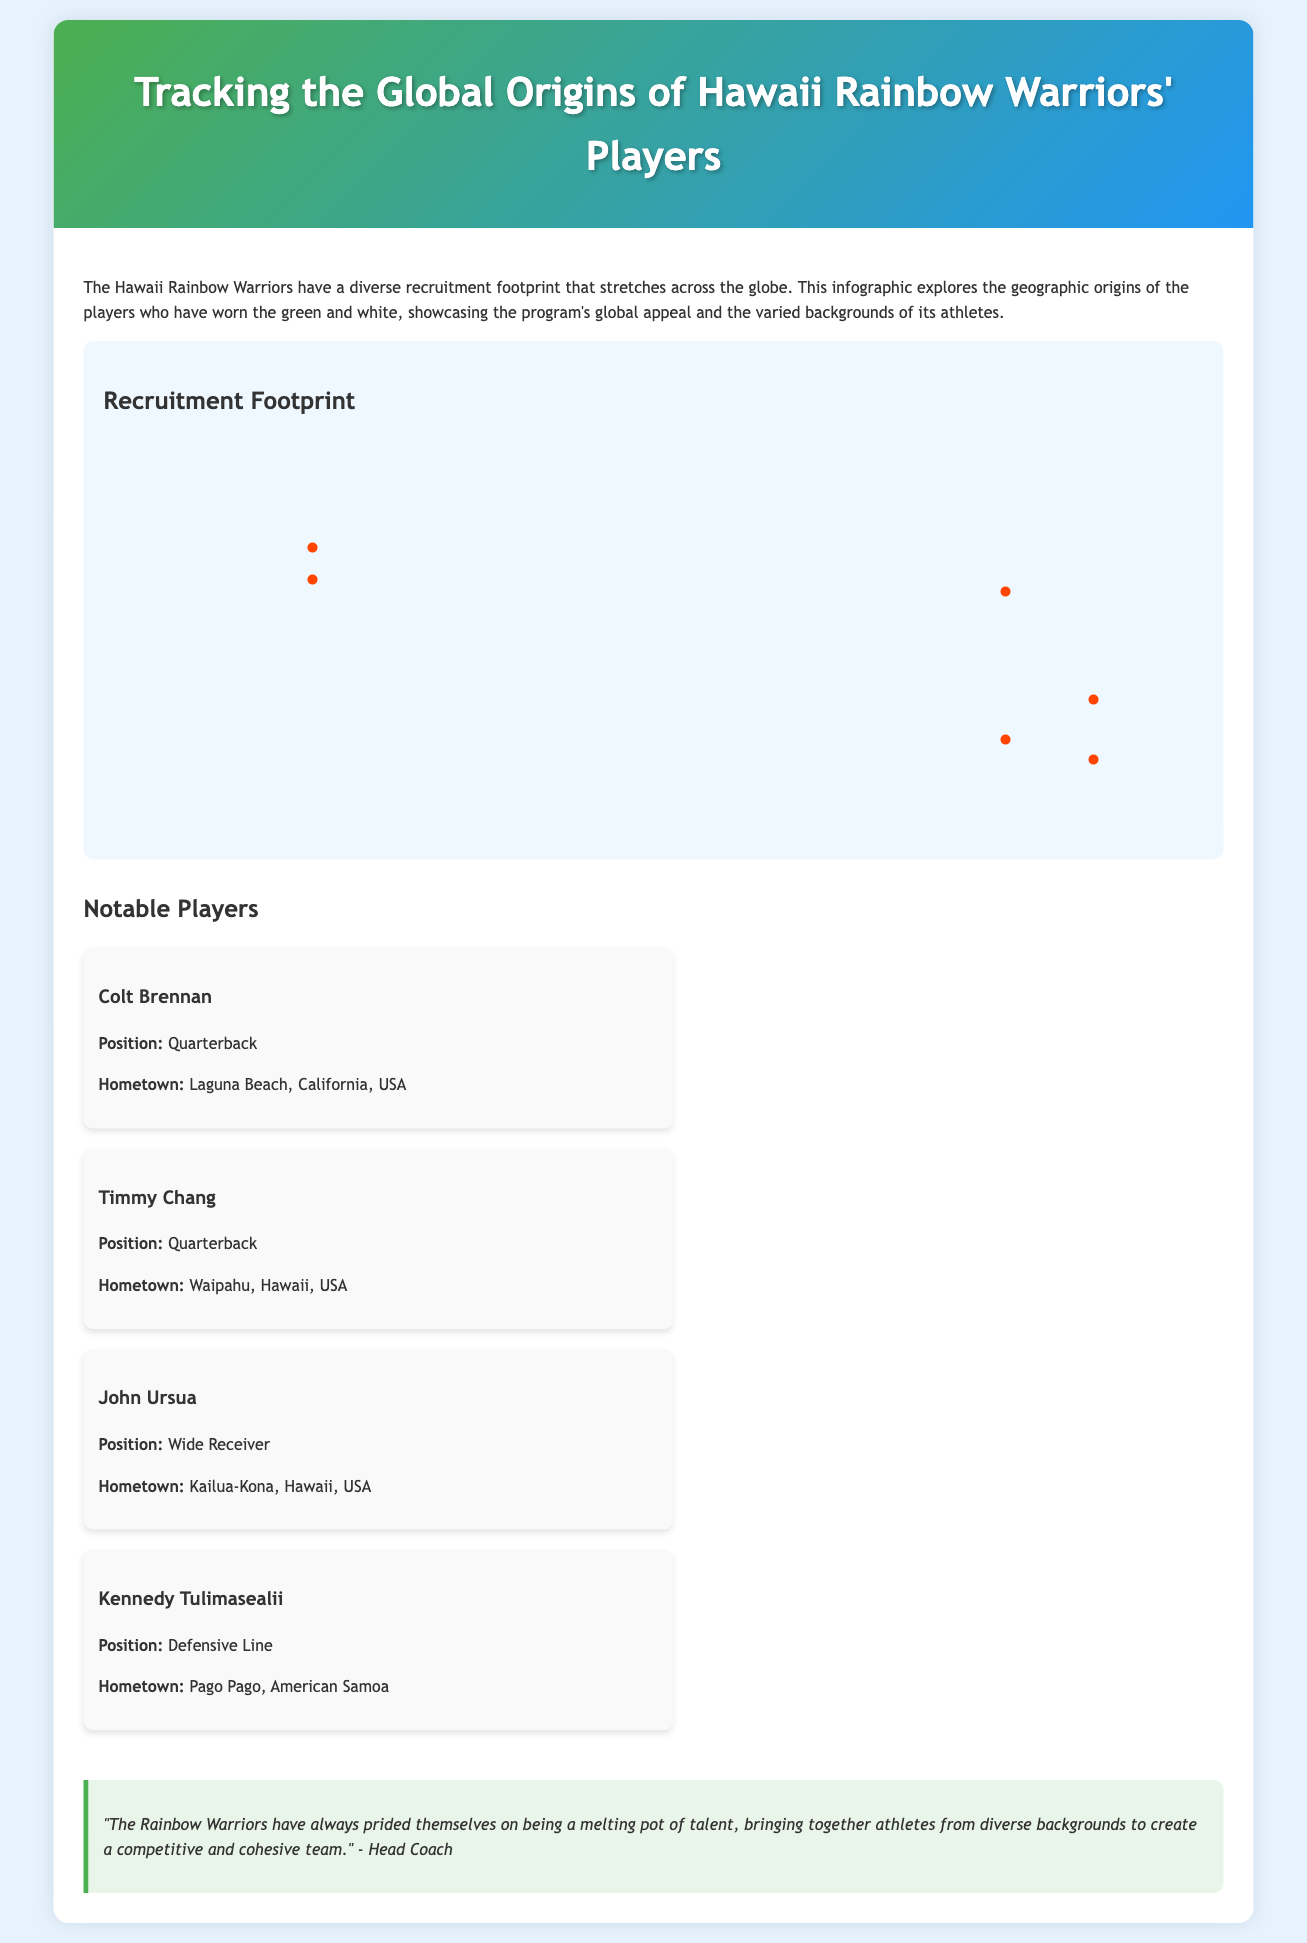what is the title of the infographic? The title of the infographic is provided in the header section of the document.
Answer: Tracking the Global Origins of Hawaii Rainbow Warriors' Players how many map points are displayed? The map points represent different geographic origins of the players, and a count yields the total number displayed on the map.
Answer: 6 who is the quarterback from Laguna Beach, California? Colt Brennan's position and hometown are specified in the player cards section of the document.
Answer: Colt Brennan which country is represented by the map point labeled "American Samoa"? The title for this map point directly correlates with the name of the location indicated on the map.
Answer: American Samoa what position does Kennedy Tulimasealii play? The player card for Kennedy Tulimasealii explicitly mentions his playing position.
Answer: Defensive Line what does the quote from the Head Coach emphasize? The quote is about the team's philosophy and the diversity of its players.
Answer: Melting pot of talent where is Timmy Chang from? The player card of Timmy Chang outlines his hometown.
Answer: Waipahu, Hawaii, USA 